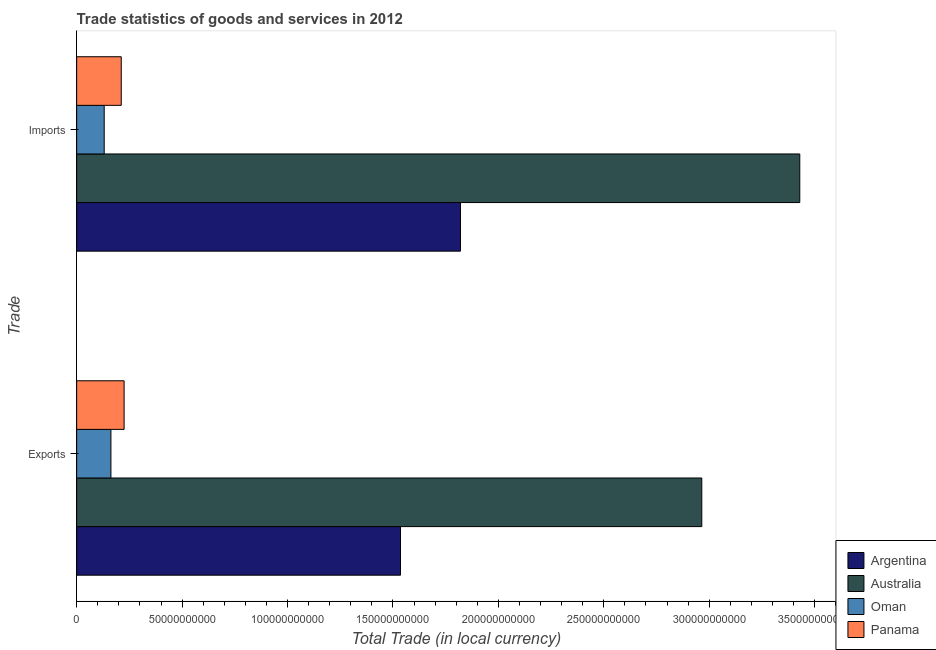What is the label of the 2nd group of bars from the top?
Offer a terse response. Exports. What is the imports of goods and services in Argentina?
Your answer should be very brief. 1.82e+11. Across all countries, what is the maximum imports of goods and services?
Provide a succinct answer. 3.43e+11. Across all countries, what is the minimum export of goods and services?
Provide a succinct answer. 1.63e+1. In which country was the imports of goods and services maximum?
Your answer should be very brief. Australia. In which country was the export of goods and services minimum?
Offer a very short reply. Oman. What is the total imports of goods and services in the graph?
Your response must be concise. 5.59e+11. What is the difference between the imports of goods and services in Oman and that in Australia?
Give a very brief answer. -3.30e+11. What is the difference between the export of goods and services in Australia and the imports of goods and services in Panama?
Your answer should be very brief. 2.75e+11. What is the average export of goods and services per country?
Provide a short and direct response. 1.22e+11. What is the difference between the imports of goods and services and export of goods and services in Australia?
Make the answer very short. 4.65e+1. In how many countries, is the export of goods and services greater than 180000000000 LCU?
Your response must be concise. 1. What is the ratio of the export of goods and services in Oman to that in Argentina?
Offer a very short reply. 0.11. What does the 4th bar from the top in Imports represents?
Keep it short and to the point. Argentina. What does the 3rd bar from the bottom in Imports represents?
Your response must be concise. Oman. How many bars are there?
Your response must be concise. 8. Are all the bars in the graph horizontal?
Offer a very short reply. Yes. Are the values on the major ticks of X-axis written in scientific E-notation?
Offer a terse response. No. Does the graph contain any zero values?
Ensure brevity in your answer.  No. What is the title of the graph?
Make the answer very short. Trade statistics of goods and services in 2012. What is the label or title of the X-axis?
Provide a succinct answer. Total Trade (in local currency). What is the label or title of the Y-axis?
Offer a very short reply. Trade. What is the Total Trade (in local currency) of Argentina in Exports?
Give a very brief answer. 1.54e+11. What is the Total Trade (in local currency) in Australia in Exports?
Provide a succinct answer. 2.96e+11. What is the Total Trade (in local currency) of Oman in Exports?
Keep it short and to the point. 1.63e+1. What is the Total Trade (in local currency) in Panama in Exports?
Your response must be concise. 2.25e+1. What is the Total Trade (in local currency) of Argentina in Imports?
Offer a terse response. 1.82e+11. What is the Total Trade (in local currency) in Australia in Imports?
Ensure brevity in your answer.  3.43e+11. What is the Total Trade (in local currency) of Oman in Imports?
Make the answer very short. 1.31e+1. What is the Total Trade (in local currency) in Panama in Imports?
Offer a terse response. 2.11e+1. Across all Trade, what is the maximum Total Trade (in local currency) of Argentina?
Ensure brevity in your answer.  1.82e+11. Across all Trade, what is the maximum Total Trade (in local currency) in Australia?
Keep it short and to the point. 3.43e+11. Across all Trade, what is the maximum Total Trade (in local currency) in Oman?
Make the answer very short. 1.63e+1. Across all Trade, what is the maximum Total Trade (in local currency) in Panama?
Your response must be concise. 2.25e+1. Across all Trade, what is the minimum Total Trade (in local currency) of Argentina?
Offer a terse response. 1.54e+11. Across all Trade, what is the minimum Total Trade (in local currency) of Australia?
Offer a very short reply. 2.96e+11. Across all Trade, what is the minimum Total Trade (in local currency) of Oman?
Make the answer very short. 1.31e+1. Across all Trade, what is the minimum Total Trade (in local currency) in Panama?
Offer a terse response. 2.11e+1. What is the total Total Trade (in local currency) of Argentina in the graph?
Keep it short and to the point. 3.36e+11. What is the total Total Trade (in local currency) in Australia in the graph?
Give a very brief answer. 6.39e+11. What is the total Total Trade (in local currency) of Oman in the graph?
Give a very brief answer. 2.93e+1. What is the total Total Trade (in local currency) of Panama in the graph?
Offer a terse response. 4.37e+1. What is the difference between the Total Trade (in local currency) in Argentina in Exports and that in Imports?
Provide a succinct answer. -2.84e+1. What is the difference between the Total Trade (in local currency) of Australia in Exports and that in Imports?
Provide a succinct answer. -4.65e+1. What is the difference between the Total Trade (in local currency) in Oman in Exports and that in Imports?
Provide a succinct answer. 3.19e+09. What is the difference between the Total Trade (in local currency) of Panama in Exports and that in Imports?
Ensure brevity in your answer.  1.36e+09. What is the difference between the Total Trade (in local currency) of Argentina in Exports and the Total Trade (in local currency) of Australia in Imports?
Your answer should be very brief. -1.89e+11. What is the difference between the Total Trade (in local currency) in Argentina in Exports and the Total Trade (in local currency) in Oman in Imports?
Offer a very short reply. 1.41e+11. What is the difference between the Total Trade (in local currency) of Argentina in Exports and the Total Trade (in local currency) of Panama in Imports?
Your response must be concise. 1.32e+11. What is the difference between the Total Trade (in local currency) of Australia in Exports and the Total Trade (in local currency) of Oman in Imports?
Your response must be concise. 2.83e+11. What is the difference between the Total Trade (in local currency) in Australia in Exports and the Total Trade (in local currency) in Panama in Imports?
Keep it short and to the point. 2.75e+11. What is the difference between the Total Trade (in local currency) of Oman in Exports and the Total Trade (in local currency) of Panama in Imports?
Your response must be concise. -4.89e+09. What is the average Total Trade (in local currency) in Argentina per Trade?
Provide a succinct answer. 1.68e+11. What is the average Total Trade (in local currency) in Australia per Trade?
Provide a short and direct response. 3.20e+11. What is the average Total Trade (in local currency) of Oman per Trade?
Keep it short and to the point. 1.47e+1. What is the average Total Trade (in local currency) of Panama per Trade?
Provide a succinct answer. 2.18e+1. What is the difference between the Total Trade (in local currency) of Argentina and Total Trade (in local currency) of Australia in Exports?
Offer a very short reply. -1.43e+11. What is the difference between the Total Trade (in local currency) in Argentina and Total Trade (in local currency) in Oman in Exports?
Your response must be concise. 1.37e+11. What is the difference between the Total Trade (in local currency) of Argentina and Total Trade (in local currency) of Panama in Exports?
Make the answer very short. 1.31e+11. What is the difference between the Total Trade (in local currency) of Australia and Total Trade (in local currency) of Oman in Exports?
Offer a terse response. 2.80e+11. What is the difference between the Total Trade (in local currency) in Australia and Total Trade (in local currency) in Panama in Exports?
Your response must be concise. 2.74e+11. What is the difference between the Total Trade (in local currency) of Oman and Total Trade (in local currency) of Panama in Exports?
Your answer should be very brief. -6.25e+09. What is the difference between the Total Trade (in local currency) in Argentina and Total Trade (in local currency) in Australia in Imports?
Offer a very short reply. -1.61e+11. What is the difference between the Total Trade (in local currency) in Argentina and Total Trade (in local currency) in Oman in Imports?
Keep it short and to the point. 1.69e+11. What is the difference between the Total Trade (in local currency) of Argentina and Total Trade (in local currency) of Panama in Imports?
Make the answer very short. 1.61e+11. What is the difference between the Total Trade (in local currency) in Australia and Total Trade (in local currency) in Oman in Imports?
Give a very brief answer. 3.30e+11. What is the difference between the Total Trade (in local currency) in Australia and Total Trade (in local currency) in Panama in Imports?
Make the answer very short. 3.22e+11. What is the difference between the Total Trade (in local currency) in Oman and Total Trade (in local currency) in Panama in Imports?
Make the answer very short. -8.08e+09. What is the ratio of the Total Trade (in local currency) of Argentina in Exports to that in Imports?
Offer a terse response. 0.84. What is the ratio of the Total Trade (in local currency) of Australia in Exports to that in Imports?
Provide a succinct answer. 0.86. What is the ratio of the Total Trade (in local currency) in Oman in Exports to that in Imports?
Offer a very short reply. 1.24. What is the ratio of the Total Trade (in local currency) of Panama in Exports to that in Imports?
Your answer should be compact. 1.06. What is the difference between the highest and the second highest Total Trade (in local currency) in Argentina?
Your answer should be compact. 2.84e+1. What is the difference between the highest and the second highest Total Trade (in local currency) in Australia?
Provide a short and direct response. 4.65e+1. What is the difference between the highest and the second highest Total Trade (in local currency) in Oman?
Keep it short and to the point. 3.19e+09. What is the difference between the highest and the second highest Total Trade (in local currency) of Panama?
Make the answer very short. 1.36e+09. What is the difference between the highest and the lowest Total Trade (in local currency) of Argentina?
Provide a succinct answer. 2.84e+1. What is the difference between the highest and the lowest Total Trade (in local currency) of Australia?
Give a very brief answer. 4.65e+1. What is the difference between the highest and the lowest Total Trade (in local currency) of Oman?
Keep it short and to the point. 3.19e+09. What is the difference between the highest and the lowest Total Trade (in local currency) in Panama?
Offer a terse response. 1.36e+09. 